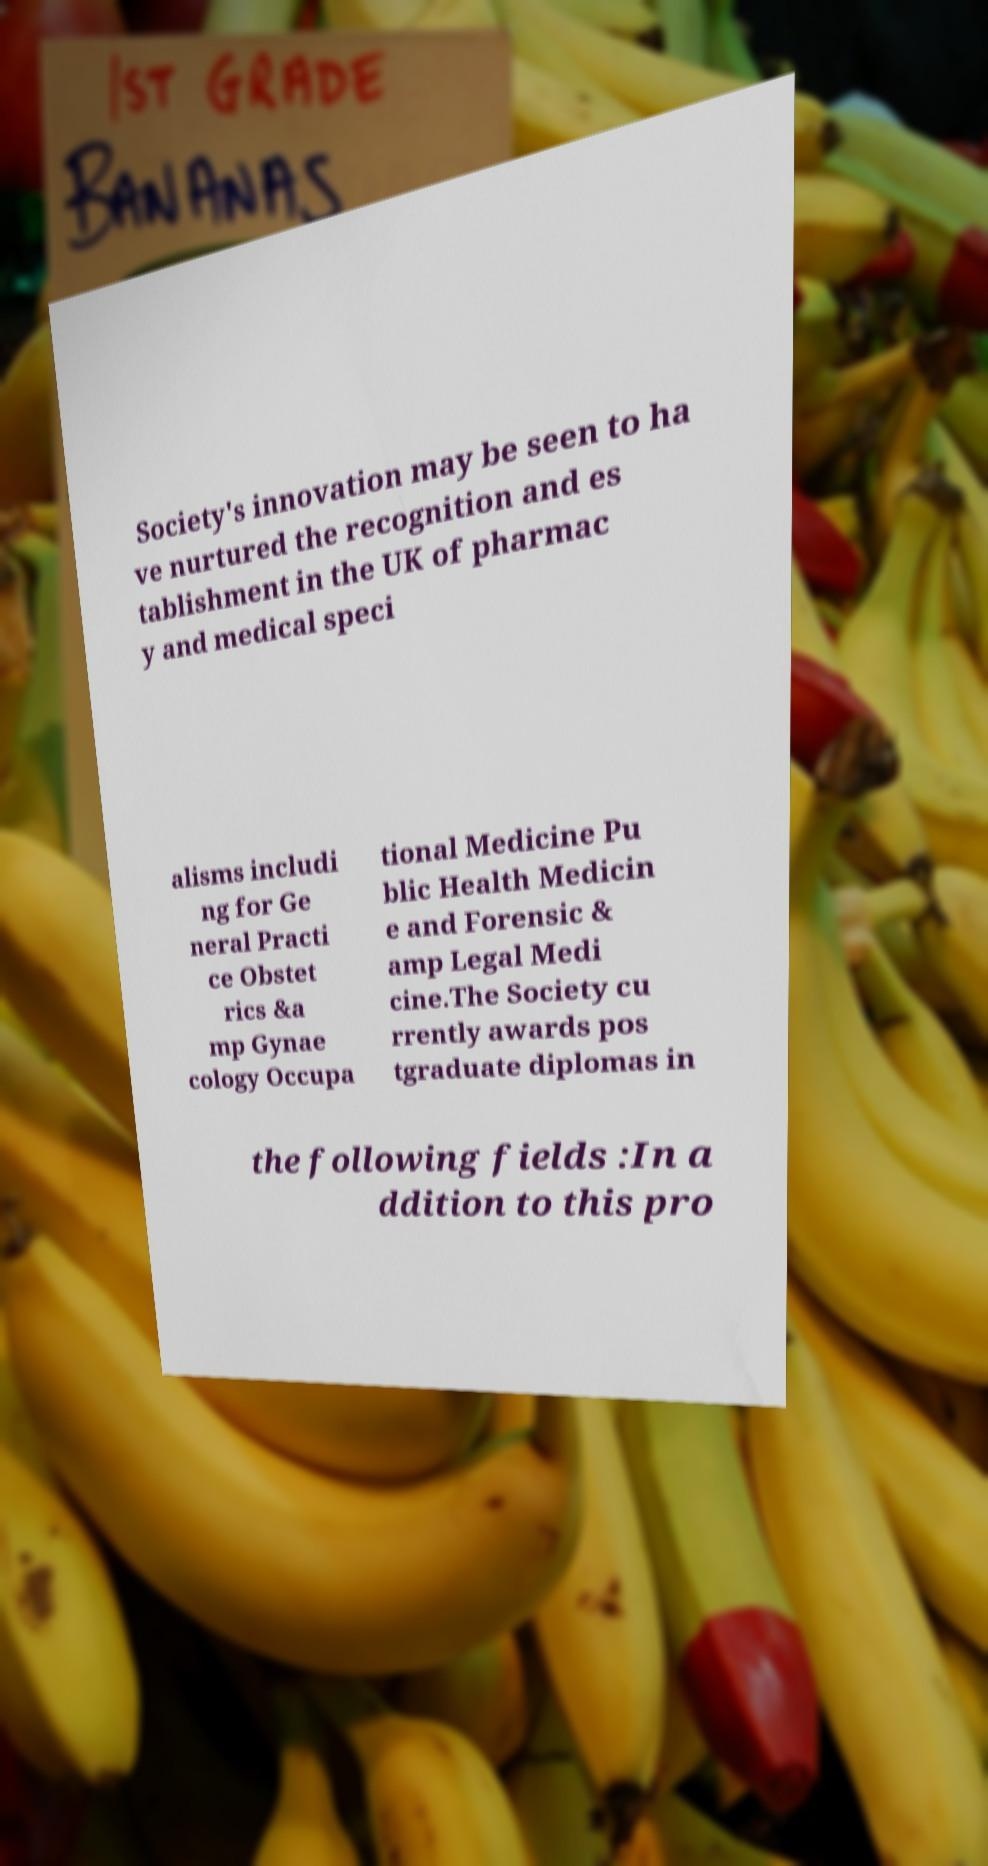For documentation purposes, I need the text within this image transcribed. Could you provide that? Society's innovation may be seen to ha ve nurtured the recognition and es tablishment in the UK of pharmac y and medical speci alisms includi ng for Ge neral Practi ce Obstet rics &a mp Gynae cology Occupa tional Medicine Pu blic Health Medicin e and Forensic & amp Legal Medi cine.The Society cu rrently awards pos tgraduate diplomas in the following fields :In a ddition to this pro 